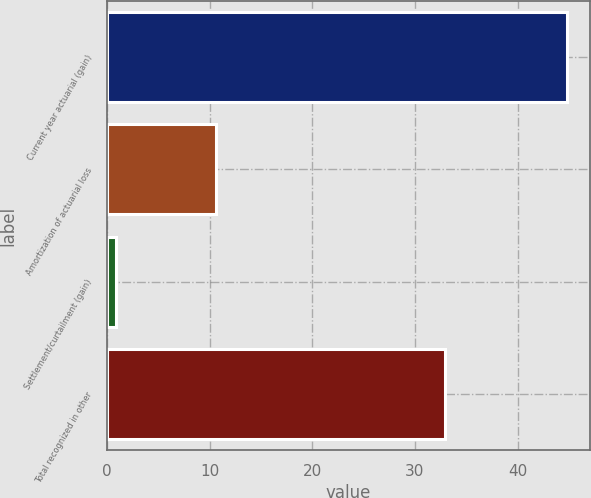Convert chart. <chart><loc_0><loc_0><loc_500><loc_500><bar_chart><fcel>Current year actuarial (gain)<fcel>Amortization of actuarial loss<fcel>Settlement/curtailment (gain)<fcel>Total recognized in other<nl><fcel>44.8<fcel>10.6<fcel>0.9<fcel>32.9<nl></chart> 